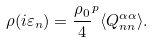Convert formula to latex. <formula><loc_0><loc_0><loc_500><loc_500>\rho ( i \varepsilon _ { n } ) = \frac { \rho _ { 0 } } { 4 } ^ { p } \langle Q _ { n n } ^ { \alpha \alpha } \rangle .</formula> 